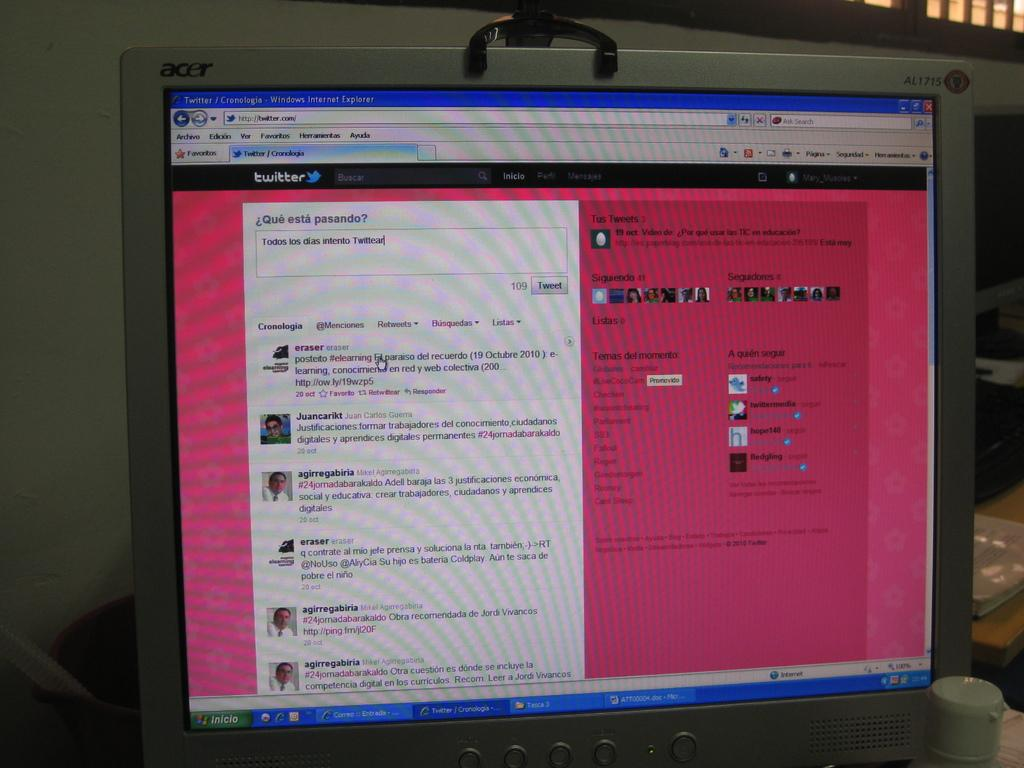Provide a one-sentence caption for the provided image. an acer computer screen open to a twitter page. 